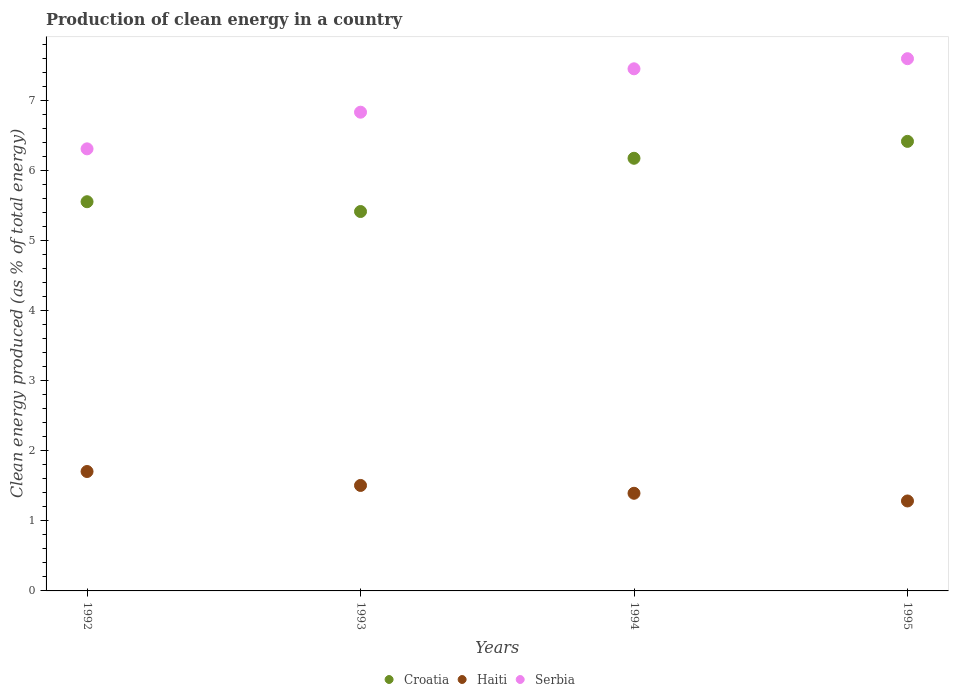How many different coloured dotlines are there?
Make the answer very short. 3. Is the number of dotlines equal to the number of legend labels?
Provide a succinct answer. Yes. What is the percentage of clean energy produced in Serbia in 1995?
Ensure brevity in your answer.  7.6. Across all years, what is the maximum percentage of clean energy produced in Serbia?
Your answer should be compact. 7.6. Across all years, what is the minimum percentage of clean energy produced in Serbia?
Make the answer very short. 6.32. In which year was the percentage of clean energy produced in Croatia maximum?
Ensure brevity in your answer.  1995. In which year was the percentage of clean energy produced in Croatia minimum?
Your response must be concise. 1993. What is the total percentage of clean energy produced in Serbia in the graph?
Your answer should be compact. 28.22. What is the difference between the percentage of clean energy produced in Croatia in 1992 and that in 1993?
Provide a short and direct response. 0.14. What is the difference between the percentage of clean energy produced in Haiti in 1992 and the percentage of clean energy produced in Serbia in 1995?
Give a very brief answer. -5.9. What is the average percentage of clean energy produced in Croatia per year?
Ensure brevity in your answer.  5.9. In the year 1994, what is the difference between the percentage of clean energy produced in Croatia and percentage of clean energy produced in Haiti?
Offer a terse response. 4.79. What is the ratio of the percentage of clean energy produced in Haiti in 1992 to that in 1994?
Make the answer very short. 1.22. Is the percentage of clean energy produced in Serbia in 1993 less than that in 1994?
Provide a succinct answer. Yes. What is the difference between the highest and the second highest percentage of clean energy produced in Serbia?
Your answer should be very brief. 0.14. What is the difference between the highest and the lowest percentage of clean energy produced in Croatia?
Provide a short and direct response. 1. In how many years, is the percentage of clean energy produced in Haiti greater than the average percentage of clean energy produced in Haiti taken over all years?
Your answer should be very brief. 2. Does the percentage of clean energy produced in Croatia monotonically increase over the years?
Ensure brevity in your answer.  No. Is the percentage of clean energy produced in Haiti strictly greater than the percentage of clean energy produced in Serbia over the years?
Offer a very short reply. No. Are the values on the major ticks of Y-axis written in scientific E-notation?
Offer a very short reply. No. Does the graph contain grids?
Provide a succinct answer. No. What is the title of the graph?
Keep it short and to the point. Production of clean energy in a country. What is the label or title of the Y-axis?
Offer a very short reply. Clean energy produced (as % of total energy). What is the Clean energy produced (as % of total energy) of Croatia in 1992?
Your answer should be very brief. 5.56. What is the Clean energy produced (as % of total energy) in Haiti in 1992?
Offer a terse response. 1.71. What is the Clean energy produced (as % of total energy) of Serbia in 1992?
Offer a very short reply. 6.32. What is the Clean energy produced (as % of total energy) in Croatia in 1993?
Give a very brief answer. 5.42. What is the Clean energy produced (as % of total energy) in Haiti in 1993?
Ensure brevity in your answer.  1.51. What is the Clean energy produced (as % of total energy) in Serbia in 1993?
Your answer should be very brief. 6.84. What is the Clean energy produced (as % of total energy) of Croatia in 1994?
Your response must be concise. 6.18. What is the Clean energy produced (as % of total energy) of Haiti in 1994?
Your answer should be compact. 1.39. What is the Clean energy produced (as % of total energy) in Serbia in 1994?
Offer a very short reply. 7.46. What is the Clean energy produced (as % of total energy) of Croatia in 1995?
Offer a very short reply. 6.42. What is the Clean energy produced (as % of total energy) of Haiti in 1995?
Your response must be concise. 1.29. What is the Clean energy produced (as % of total energy) of Serbia in 1995?
Offer a terse response. 7.6. Across all years, what is the maximum Clean energy produced (as % of total energy) in Croatia?
Give a very brief answer. 6.42. Across all years, what is the maximum Clean energy produced (as % of total energy) of Haiti?
Provide a short and direct response. 1.71. Across all years, what is the maximum Clean energy produced (as % of total energy) of Serbia?
Give a very brief answer. 7.6. Across all years, what is the minimum Clean energy produced (as % of total energy) in Croatia?
Provide a short and direct response. 5.42. Across all years, what is the minimum Clean energy produced (as % of total energy) in Haiti?
Give a very brief answer. 1.29. Across all years, what is the minimum Clean energy produced (as % of total energy) of Serbia?
Make the answer very short. 6.32. What is the total Clean energy produced (as % of total energy) in Croatia in the graph?
Offer a very short reply. 23.58. What is the total Clean energy produced (as % of total energy) of Haiti in the graph?
Your response must be concise. 5.89. What is the total Clean energy produced (as % of total energy) of Serbia in the graph?
Offer a very short reply. 28.22. What is the difference between the Clean energy produced (as % of total energy) of Croatia in 1992 and that in 1993?
Keep it short and to the point. 0.14. What is the difference between the Clean energy produced (as % of total energy) in Haiti in 1992 and that in 1993?
Make the answer very short. 0.2. What is the difference between the Clean energy produced (as % of total energy) of Serbia in 1992 and that in 1993?
Your answer should be compact. -0.52. What is the difference between the Clean energy produced (as % of total energy) of Croatia in 1992 and that in 1994?
Give a very brief answer. -0.62. What is the difference between the Clean energy produced (as % of total energy) in Haiti in 1992 and that in 1994?
Your answer should be compact. 0.31. What is the difference between the Clean energy produced (as % of total energy) in Serbia in 1992 and that in 1994?
Ensure brevity in your answer.  -1.14. What is the difference between the Clean energy produced (as % of total energy) of Croatia in 1992 and that in 1995?
Your answer should be compact. -0.86. What is the difference between the Clean energy produced (as % of total energy) in Haiti in 1992 and that in 1995?
Make the answer very short. 0.42. What is the difference between the Clean energy produced (as % of total energy) of Serbia in 1992 and that in 1995?
Ensure brevity in your answer.  -1.29. What is the difference between the Clean energy produced (as % of total energy) in Croatia in 1993 and that in 1994?
Your response must be concise. -0.76. What is the difference between the Clean energy produced (as % of total energy) of Haiti in 1993 and that in 1994?
Your response must be concise. 0.11. What is the difference between the Clean energy produced (as % of total energy) of Serbia in 1993 and that in 1994?
Provide a succinct answer. -0.62. What is the difference between the Clean energy produced (as % of total energy) of Croatia in 1993 and that in 1995?
Provide a short and direct response. -1. What is the difference between the Clean energy produced (as % of total energy) of Haiti in 1993 and that in 1995?
Your response must be concise. 0.22. What is the difference between the Clean energy produced (as % of total energy) of Serbia in 1993 and that in 1995?
Give a very brief answer. -0.76. What is the difference between the Clean energy produced (as % of total energy) of Croatia in 1994 and that in 1995?
Keep it short and to the point. -0.24. What is the difference between the Clean energy produced (as % of total energy) in Haiti in 1994 and that in 1995?
Ensure brevity in your answer.  0.11. What is the difference between the Clean energy produced (as % of total energy) in Serbia in 1994 and that in 1995?
Provide a succinct answer. -0.14. What is the difference between the Clean energy produced (as % of total energy) of Croatia in 1992 and the Clean energy produced (as % of total energy) of Haiti in 1993?
Keep it short and to the point. 4.05. What is the difference between the Clean energy produced (as % of total energy) of Croatia in 1992 and the Clean energy produced (as % of total energy) of Serbia in 1993?
Give a very brief answer. -1.28. What is the difference between the Clean energy produced (as % of total energy) of Haiti in 1992 and the Clean energy produced (as % of total energy) of Serbia in 1993?
Your answer should be very brief. -5.13. What is the difference between the Clean energy produced (as % of total energy) in Croatia in 1992 and the Clean energy produced (as % of total energy) in Haiti in 1994?
Provide a short and direct response. 4.16. What is the difference between the Clean energy produced (as % of total energy) in Croatia in 1992 and the Clean energy produced (as % of total energy) in Serbia in 1994?
Keep it short and to the point. -1.9. What is the difference between the Clean energy produced (as % of total energy) in Haiti in 1992 and the Clean energy produced (as % of total energy) in Serbia in 1994?
Provide a succinct answer. -5.75. What is the difference between the Clean energy produced (as % of total energy) of Croatia in 1992 and the Clean energy produced (as % of total energy) of Haiti in 1995?
Your answer should be compact. 4.27. What is the difference between the Clean energy produced (as % of total energy) in Croatia in 1992 and the Clean energy produced (as % of total energy) in Serbia in 1995?
Provide a short and direct response. -2.04. What is the difference between the Clean energy produced (as % of total energy) of Haiti in 1992 and the Clean energy produced (as % of total energy) of Serbia in 1995?
Offer a terse response. -5.9. What is the difference between the Clean energy produced (as % of total energy) of Croatia in 1993 and the Clean energy produced (as % of total energy) of Haiti in 1994?
Your answer should be very brief. 4.02. What is the difference between the Clean energy produced (as % of total energy) in Croatia in 1993 and the Clean energy produced (as % of total energy) in Serbia in 1994?
Your answer should be very brief. -2.04. What is the difference between the Clean energy produced (as % of total energy) in Haiti in 1993 and the Clean energy produced (as % of total energy) in Serbia in 1994?
Your response must be concise. -5.95. What is the difference between the Clean energy produced (as % of total energy) in Croatia in 1993 and the Clean energy produced (as % of total energy) in Haiti in 1995?
Offer a very short reply. 4.13. What is the difference between the Clean energy produced (as % of total energy) in Croatia in 1993 and the Clean energy produced (as % of total energy) in Serbia in 1995?
Provide a succinct answer. -2.18. What is the difference between the Clean energy produced (as % of total energy) of Haiti in 1993 and the Clean energy produced (as % of total energy) of Serbia in 1995?
Give a very brief answer. -6.1. What is the difference between the Clean energy produced (as % of total energy) in Croatia in 1994 and the Clean energy produced (as % of total energy) in Haiti in 1995?
Give a very brief answer. 4.9. What is the difference between the Clean energy produced (as % of total energy) in Croatia in 1994 and the Clean energy produced (as % of total energy) in Serbia in 1995?
Keep it short and to the point. -1.42. What is the difference between the Clean energy produced (as % of total energy) in Haiti in 1994 and the Clean energy produced (as % of total energy) in Serbia in 1995?
Ensure brevity in your answer.  -6.21. What is the average Clean energy produced (as % of total energy) in Croatia per year?
Keep it short and to the point. 5.9. What is the average Clean energy produced (as % of total energy) in Haiti per year?
Keep it short and to the point. 1.47. What is the average Clean energy produced (as % of total energy) of Serbia per year?
Keep it short and to the point. 7.05. In the year 1992, what is the difference between the Clean energy produced (as % of total energy) in Croatia and Clean energy produced (as % of total energy) in Haiti?
Give a very brief answer. 3.85. In the year 1992, what is the difference between the Clean energy produced (as % of total energy) in Croatia and Clean energy produced (as % of total energy) in Serbia?
Provide a short and direct response. -0.76. In the year 1992, what is the difference between the Clean energy produced (as % of total energy) in Haiti and Clean energy produced (as % of total energy) in Serbia?
Your response must be concise. -4.61. In the year 1993, what is the difference between the Clean energy produced (as % of total energy) in Croatia and Clean energy produced (as % of total energy) in Haiti?
Your answer should be very brief. 3.91. In the year 1993, what is the difference between the Clean energy produced (as % of total energy) of Croatia and Clean energy produced (as % of total energy) of Serbia?
Keep it short and to the point. -1.42. In the year 1993, what is the difference between the Clean energy produced (as % of total energy) of Haiti and Clean energy produced (as % of total energy) of Serbia?
Your answer should be very brief. -5.33. In the year 1994, what is the difference between the Clean energy produced (as % of total energy) in Croatia and Clean energy produced (as % of total energy) in Haiti?
Provide a succinct answer. 4.79. In the year 1994, what is the difference between the Clean energy produced (as % of total energy) in Croatia and Clean energy produced (as % of total energy) in Serbia?
Give a very brief answer. -1.28. In the year 1994, what is the difference between the Clean energy produced (as % of total energy) in Haiti and Clean energy produced (as % of total energy) in Serbia?
Make the answer very short. -6.06. In the year 1995, what is the difference between the Clean energy produced (as % of total energy) of Croatia and Clean energy produced (as % of total energy) of Haiti?
Your answer should be compact. 5.14. In the year 1995, what is the difference between the Clean energy produced (as % of total energy) in Croatia and Clean energy produced (as % of total energy) in Serbia?
Offer a very short reply. -1.18. In the year 1995, what is the difference between the Clean energy produced (as % of total energy) of Haiti and Clean energy produced (as % of total energy) of Serbia?
Your answer should be compact. -6.32. What is the ratio of the Clean energy produced (as % of total energy) of Croatia in 1992 to that in 1993?
Keep it short and to the point. 1.03. What is the ratio of the Clean energy produced (as % of total energy) in Haiti in 1992 to that in 1993?
Make the answer very short. 1.13. What is the ratio of the Clean energy produced (as % of total energy) in Serbia in 1992 to that in 1993?
Offer a very short reply. 0.92. What is the ratio of the Clean energy produced (as % of total energy) in Croatia in 1992 to that in 1994?
Ensure brevity in your answer.  0.9. What is the ratio of the Clean energy produced (as % of total energy) of Haiti in 1992 to that in 1994?
Keep it short and to the point. 1.22. What is the ratio of the Clean energy produced (as % of total energy) of Serbia in 1992 to that in 1994?
Your response must be concise. 0.85. What is the ratio of the Clean energy produced (as % of total energy) in Croatia in 1992 to that in 1995?
Your response must be concise. 0.87. What is the ratio of the Clean energy produced (as % of total energy) in Haiti in 1992 to that in 1995?
Offer a very short reply. 1.33. What is the ratio of the Clean energy produced (as % of total energy) in Serbia in 1992 to that in 1995?
Ensure brevity in your answer.  0.83. What is the ratio of the Clean energy produced (as % of total energy) of Croatia in 1993 to that in 1994?
Give a very brief answer. 0.88. What is the ratio of the Clean energy produced (as % of total energy) in Haiti in 1993 to that in 1994?
Your answer should be very brief. 1.08. What is the ratio of the Clean energy produced (as % of total energy) of Serbia in 1993 to that in 1994?
Provide a short and direct response. 0.92. What is the ratio of the Clean energy produced (as % of total energy) in Croatia in 1993 to that in 1995?
Give a very brief answer. 0.84. What is the ratio of the Clean energy produced (as % of total energy) in Haiti in 1993 to that in 1995?
Provide a succinct answer. 1.17. What is the ratio of the Clean energy produced (as % of total energy) of Serbia in 1993 to that in 1995?
Your answer should be very brief. 0.9. What is the ratio of the Clean energy produced (as % of total energy) in Croatia in 1994 to that in 1995?
Ensure brevity in your answer.  0.96. What is the ratio of the Clean energy produced (as % of total energy) in Haiti in 1994 to that in 1995?
Your answer should be very brief. 1.09. What is the difference between the highest and the second highest Clean energy produced (as % of total energy) of Croatia?
Offer a terse response. 0.24. What is the difference between the highest and the second highest Clean energy produced (as % of total energy) of Haiti?
Make the answer very short. 0.2. What is the difference between the highest and the second highest Clean energy produced (as % of total energy) in Serbia?
Provide a short and direct response. 0.14. What is the difference between the highest and the lowest Clean energy produced (as % of total energy) of Haiti?
Provide a short and direct response. 0.42. What is the difference between the highest and the lowest Clean energy produced (as % of total energy) of Serbia?
Offer a very short reply. 1.29. 